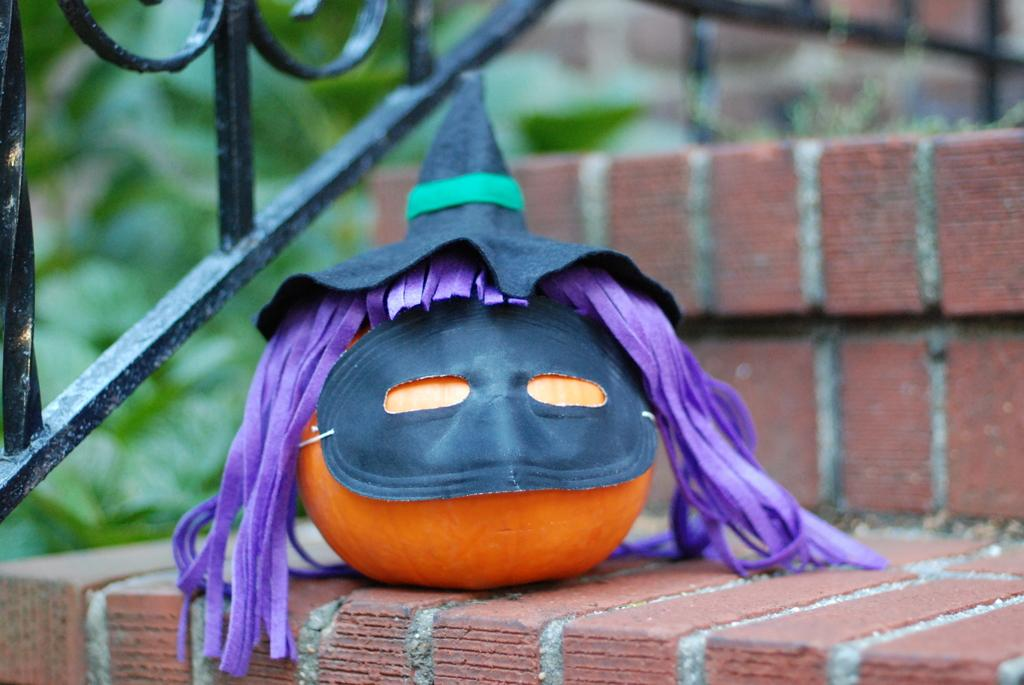What is the color of the pumpkin in the image? The pumpkin in the image is orange. What is the color and material of the grill in the image? The grill in the image is black and made of iron. How many lizards can be seen sitting on the desk in the image? There are no lizards or desks present in the image; it only features an orange pumpkin and a black iron grill. 